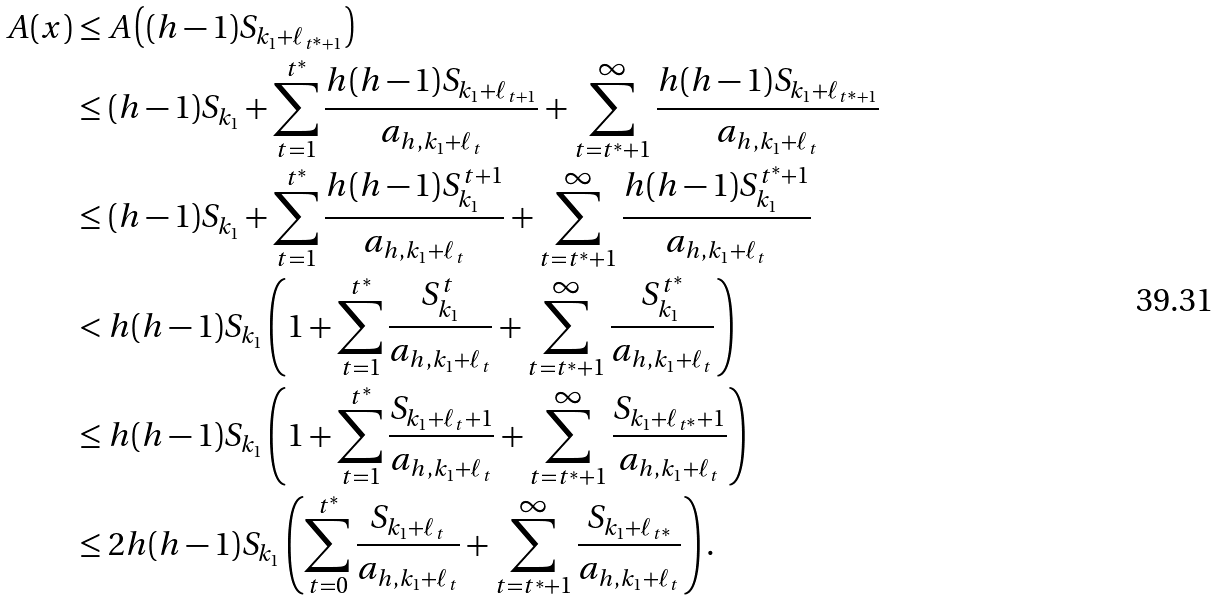Convert formula to latex. <formula><loc_0><loc_0><loc_500><loc_500>A ( x ) & \leq A \left ( ( h - 1 ) S _ { k _ { 1 } + \ell _ { t ^ { * } + 1 } } \right ) \\ & \leq ( h - 1 ) S _ { k _ { 1 } } + \sum _ { t = 1 } ^ { t ^ { * } } \frac { h ( h - 1 ) S _ { k _ { 1 } + \ell _ { t + 1 } } } { a _ { h , { k _ { 1 } } + \ell _ { t } } } + \sum _ { t = t ^ { * } + 1 } ^ { \infty } \frac { h ( h - 1 ) S _ { k _ { 1 } + \ell _ { t ^ { * } + 1 } } } { a _ { h , { k _ { 1 } } + \ell _ { t } } } \\ & \leq ( h - 1 ) S _ { k _ { 1 } } + \sum _ { t = 1 } ^ { t ^ { * } } \frac { h ( h - 1 ) S _ { k _ { 1 } } ^ { t + 1 } } { a _ { h , { k _ { 1 } } + \ell _ { t } } } + \sum _ { t = t ^ { * } + 1 } ^ { \infty } \frac { h ( h - 1 ) S _ { k _ { 1 } } ^ { t ^ { * } + 1 } } { a _ { h , { k _ { 1 } } + \ell _ { t } } } \\ & < h ( h - 1 ) S _ { k _ { 1 } } \left ( 1 + \sum _ { t = 1 } ^ { t ^ { * } } \frac { S _ { k _ { 1 } } ^ { t } } { a _ { h , { k _ { 1 } } + \ell _ { t } } } + \sum _ { t = t ^ { * } + 1 } ^ { \infty } \frac { S _ { k _ { 1 } } ^ { t ^ { * } } } { a _ { h , { k _ { 1 } } + \ell _ { t } } } \right ) \\ & \leq h ( h - 1 ) S _ { k _ { 1 } } \left ( 1 + \sum _ { t = 1 } ^ { t ^ { * } } \frac { S _ { k _ { 1 } + \ell _ { t } + 1 } } { a _ { h , { k _ { 1 } } + \ell _ { t } } } + \sum _ { t = t ^ { * } + 1 } ^ { \infty } \frac { S _ { k _ { 1 } + \ell _ { t ^ { * } } + 1 } } { a _ { h , { k _ { 1 } } + \ell _ { t } } } \right ) \\ & \leq 2 h ( h - 1 ) S _ { k _ { 1 } } \left ( \sum _ { t = 0 } ^ { t ^ { * } } \frac { S _ { k _ { 1 } + \ell _ { t } } } { a _ { h , { k _ { 1 } } + \ell _ { t } } } + \sum _ { t = t ^ { * } + 1 } ^ { \infty } \frac { S _ { k _ { 1 } + \ell _ { t ^ { * } } } } { a _ { h , { k _ { 1 } } + \ell _ { t } } } \right ) .</formula> 